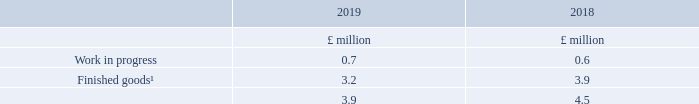8. Stocks
Note
1. Finished goods in 2018 includes £2.2 million relating to deferred costs which has been reclassified from prepayments; see note 1 for further details.
There were no stock write-downs recognised in the period (2018 nil) and there were no reversals of prior period stock write-downs (2018 nil).
No stock is carried at fair value less costs to sell (2018 nil).
What does finished goods in 2018 include? £2.2 million relating to deferred costs which has been reclassified from prepayments. Was there any stock write-downs recognised in the period? There were no stock write-downs recognised in the period. What are the types of stocks in the table? Work in progress, finished goods. In which year was the amount of work in progress larger? 0.7>0.6
Answer: 2019. What was the change in the amount of stocks?
Answer scale should be: million. 3.9-4.5
Answer: -0.6. What was the percentage change in the amount of stocks?
Answer scale should be: percent. (3.9-4.5)/4.5
Answer: -13.33. 